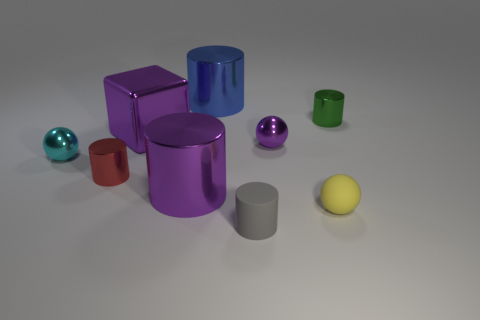Is the tiny cylinder that is in front of the small rubber ball made of the same material as the cube?
Your answer should be very brief. No. What number of other objects are the same color as the big shiny cube?
Offer a very short reply. 2. How many other objects are there of the same shape as the tiny cyan metallic object?
Your response must be concise. 2. Is the shape of the rubber object behind the gray cylinder the same as the large purple metallic object that is in front of the red cylinder?
Offer a terse response. No. Is the number of cubes in front of the tiny yellow matte object the same as the number of big purple metal blocks right of the tiny purple ball?
Offer a terse response. Yes. What is the shape of the tiny object on the left side of the tiny metal cylinder that is in front of the small thing to the right of the rubber ball?
Keep it short and to the point. Sphere. Does the tiny ball behind the cyan ball have the same material as the cylinder right of the small gray object?
Keep it short and to the point. Yes. There is a large shiny thing that is behind the green cylinder; what is its shape?
Keep it short and to the point. Cylinder. Are there fewer blocks than tiny yellow metallic cylinders?
Offer a terse response. No. There is a object that is behind the tiny shiny object behind the purple cube; are there any small cyan balls behind it?
Ensure brevity in your answer.  No. 